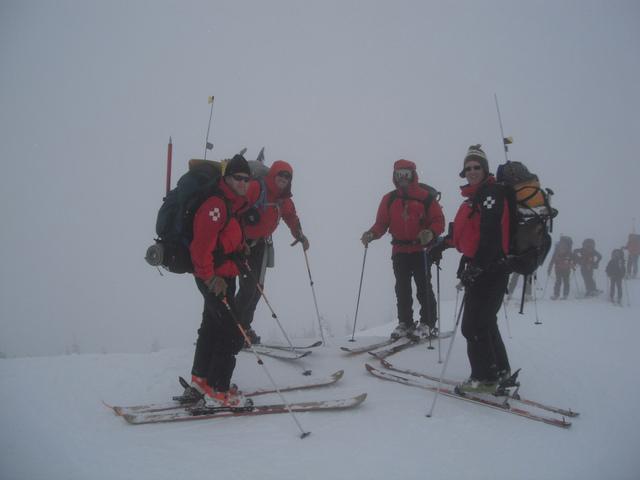How many men are riding skis?
Give a very brief answer. 4. How many backpacks are there?
Give a very brief answer. 2. How many ski are in the picture?
Give a very brief answer. 2. How many people are in the photo?
Give a very brief answer. 4. How many people are wearing an orange shirt?
Give a very brief answer. 0. 